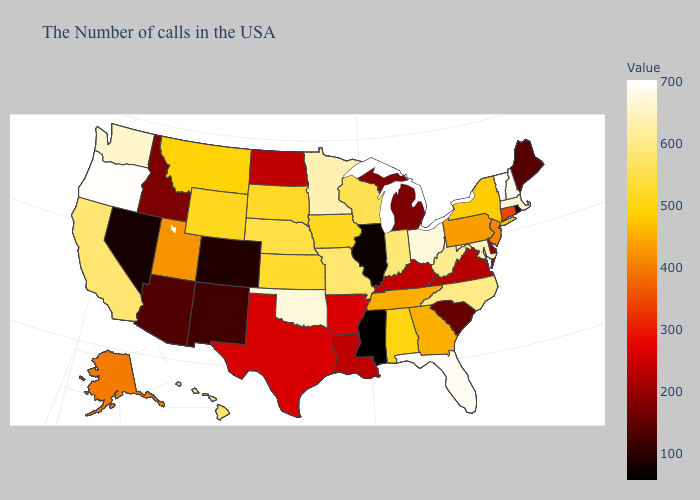Among the states that border Massachusetts , which have the lowest value?
Be succinct. Rhode Island. Does Mississippi have the lowest value in the USA?
Answer briefly. Yes. Is the legend a continuous bar?
Answer briefly. Yes. Among the states that border North Dakota , which have the lowest value?
Answer briefly. Montana. Which states have the lowest value in the West?
Answer briefly. Nevada. Does Montana have the lowest value in the West?
Write a very short answer. No. Does Wyoming have a lower value than Pennsylvania?
Quick response, please. No. Among the states that border Rhode Island , which have the highest value?
Answer briefly. Massachusetts. 